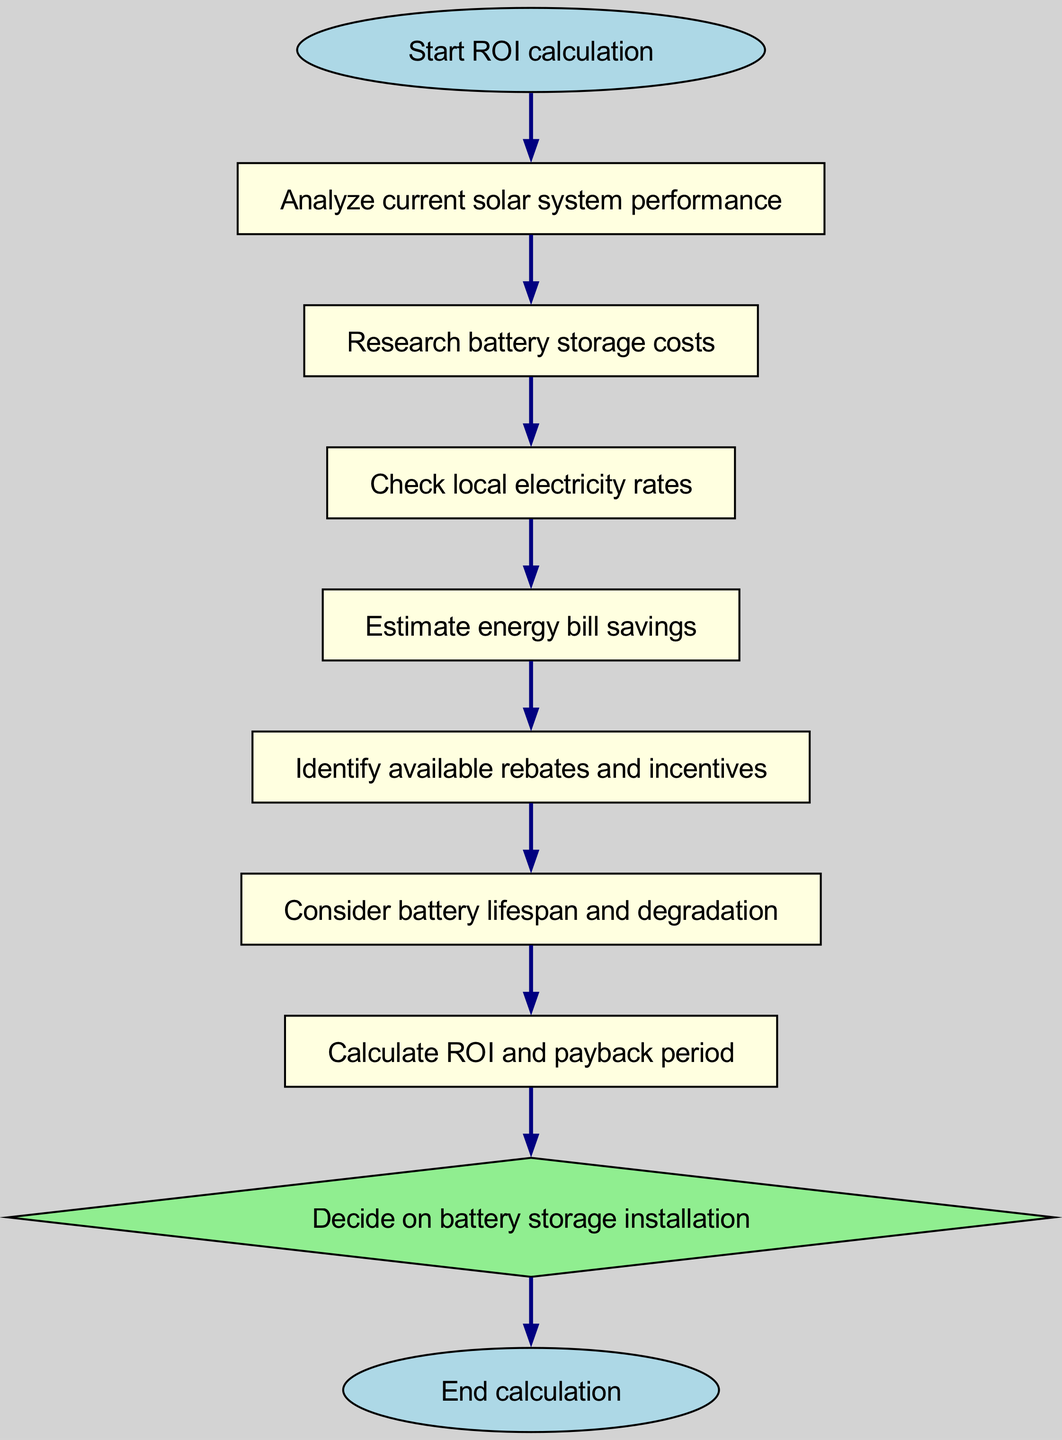What is the first step in the ROI calculation? The first step is represented by the "Start ROI calculation" node, where the process begins.
Answer: Start ROI calculation How many total nodes are in the diagram? The diagram has ten nodes, including the start and end points, and each instruction along the flow is represented as a node.
Answer: Ten What is the final step before making a decision? The final step before making a decision is the "Calculate ROI and payback period" node, which is critical for determining the financial viability of the battery storage.
Answer: Calculate ROI and payback period Which step involves identifying incentives? The step that involves identifying incentives is labeled as "Identify available rebates and incentives," which is essential for understanding potential cost reductions.
Answer: Identify available rebates and incentives What type of decision is made in the diagram? The diagram features a decision-making step that asks whether to proceed with battery storage installation based on the analysis performed throughout the flow.
Answer: Decide on battery storage installation What is analyzed after the current solar system performance? After analyzing current solar system performance, the next step is to "Research battery storage costs," which assesses the financial investment required for implementing battery storage.
Answer: Research battery storage costs How does the flow progress from energy prices to savings? The flow progresses by first checking local electricity rates in the "Check local electricity rates" step, which informs the subsequent step of estimating energy bill savings based on those rates.
Answer: Estimate energy bill savings What is the shape of the decision node in the diagram? The decision node in the diagram is represented as a diamond shape, indicating a point where a choice is made based on previous calculations.
Answer: Diamond What must be considered regarding the battery and its performance? The consideration involves "Consider battery lifespan and degradation," which addresses how the battery's efficiency may decline over time and how that affects ROI.
Answer: Consider battery lifespan and degradation 